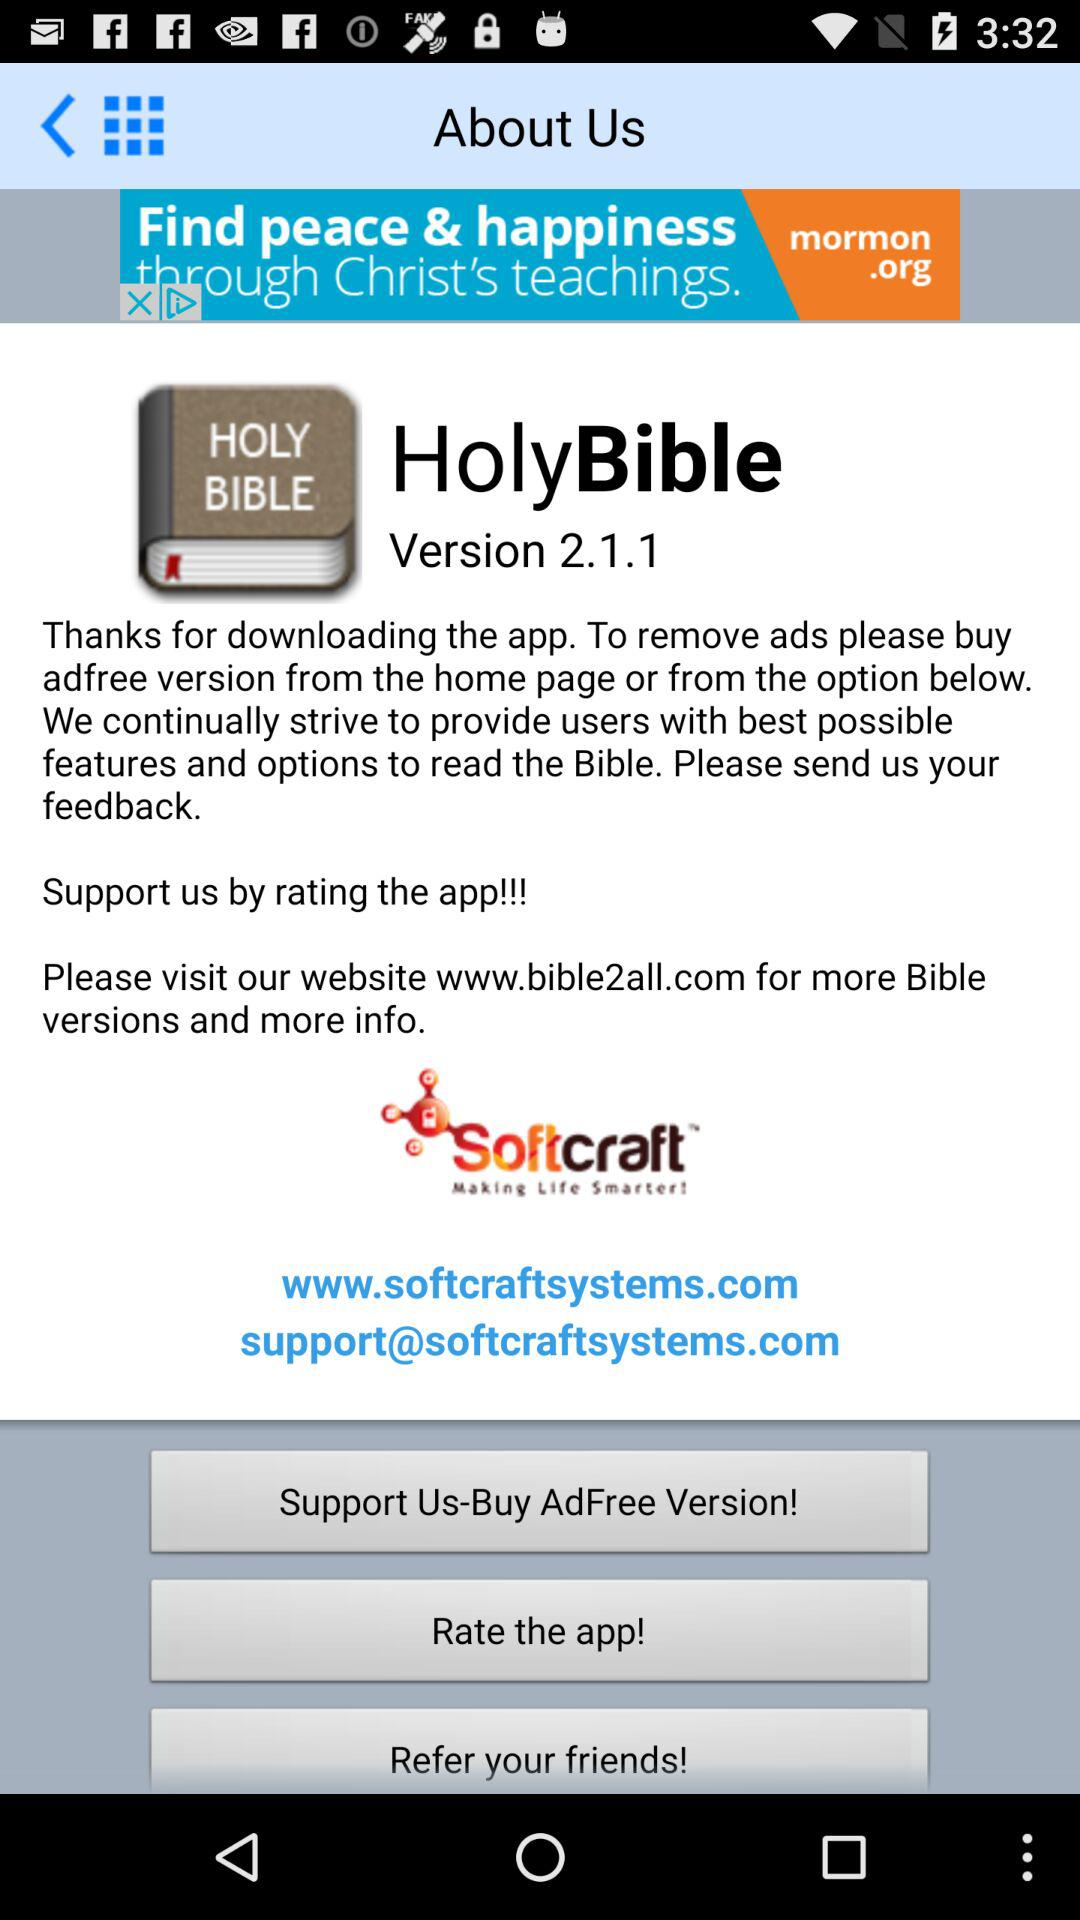What is the application name? The application name is "HolyBible". 